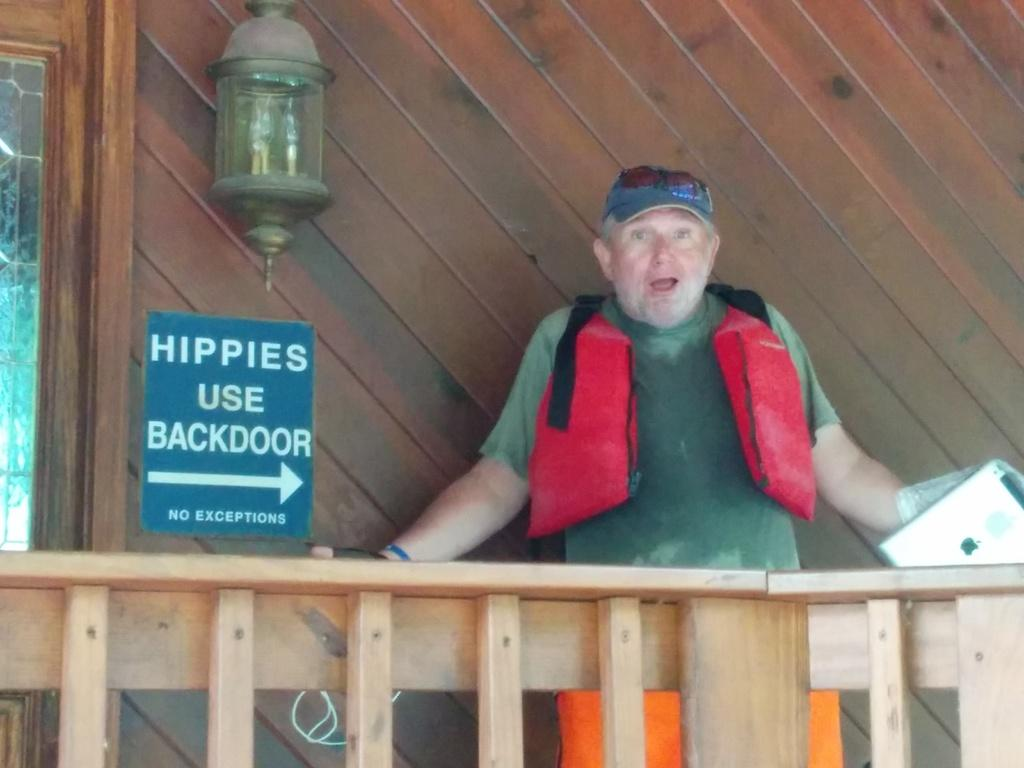What is the man in the image doing? The man is standing in the image and holding a gadget. What can be seen on the board in the image? The facts provided do not mention any details about the board, so we cannot answer this question definitively. What type of light is present in the image? There is a light on a wooden wall in the image. What architectural feature is present in the image? There is a door in the image. What type of barrier is visible in the image? There is a fence in the image. What is the man's chance of winning the lottery in the image? There is no information about the lottery or any gambling activity in the image, so we cannot answer this question definitively. 